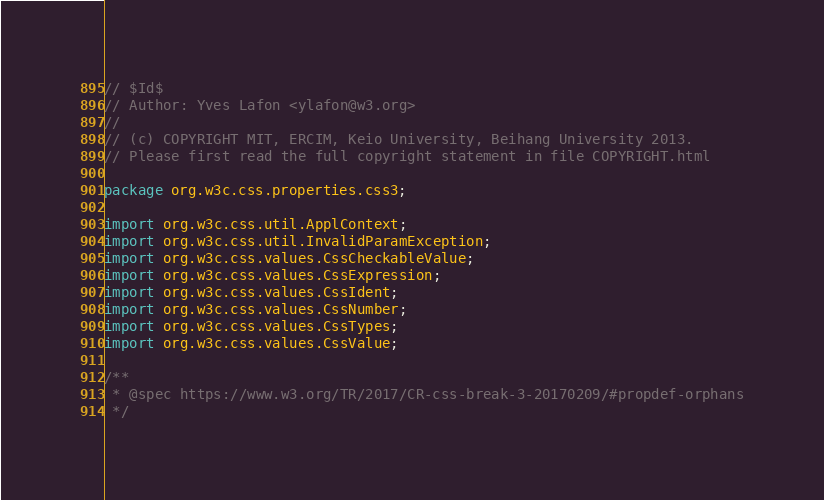Convert code to text. <code><loc_0><loc_0><loc_500><loc_500><_Java_>// $Id$
// Author: Yves Lafon <ylafon@w3.org>
//
// (c) COPYRIGHT MIT, ERCIM, Keio University, Beihang University 2013.
// Please first read the full copyright statement in file COPYRIGHT.html

package org.w3c.css.properties.css3;

import org.w3c.css.util.ApplContext;
import org.w3c.css.util.InvalidParamException;
import org.w3c.css.values.CssCheckableValue;
import org.w3c.css.values.CssExpression;
import org.w3c.css.values.CssIdent;
import org.w3c.css.values.CssNumber;
import org.w3c.css.values.CssTypes;
import org.w3c.css.values.CssValue;

/**
 * @spec https://www.w3.org/TR/2017/CR-css-break-3-20170209/#propdef-orphans
 */</code> 